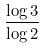<formula> <loc_0><loc_0><loc_500><loc_500>\frac { \log 3 } { \log 2 }</formula> 